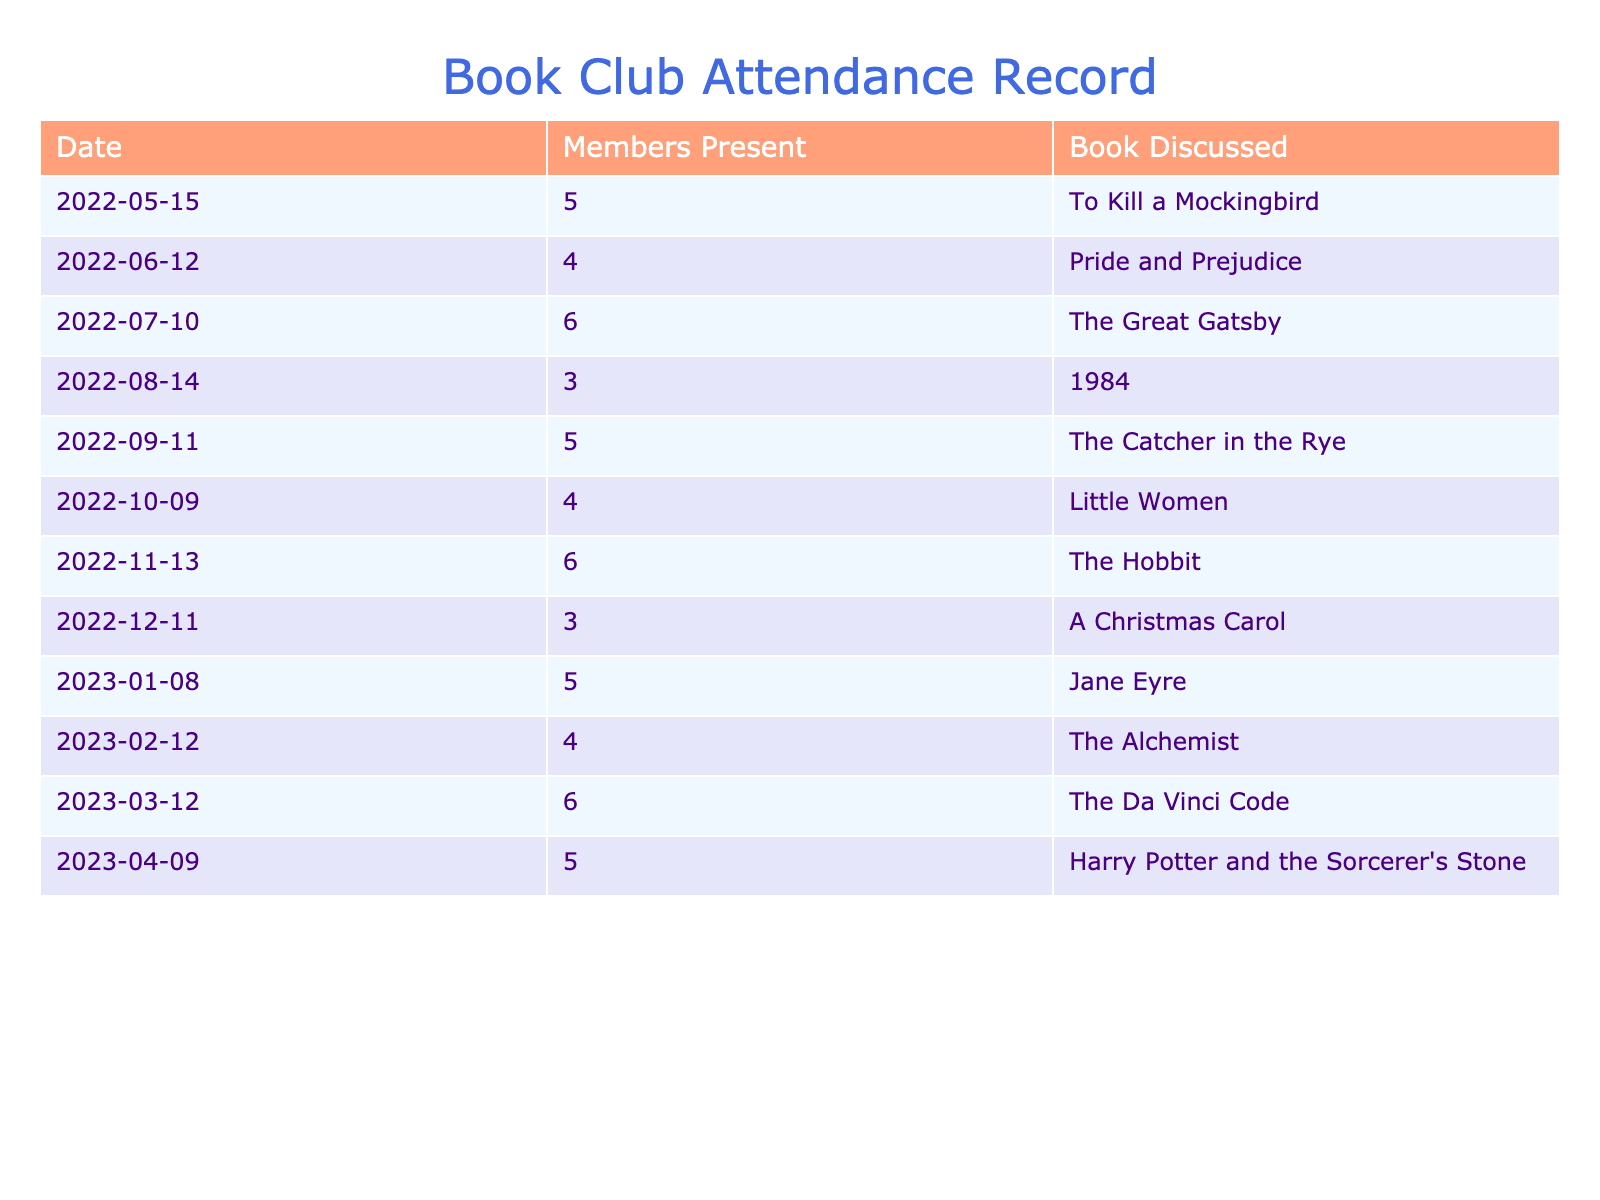What was the highest number of members present at a meeting? Looking through the "Members Present" column, the highest number noted is 6, observed on three occasions: July 10, November 13, and March 12.
Answer: 6 What book was discussed during the meeting with the least members present? The meeting with the least members present had only 3 attendees and occurred on August 14. The book discussed that day was "1984".
Answer: 1984 How many meetings had more than 5 members present? Counting the meetings listed, there are 4 instances where more than 5 members attended: July 10, November 13, and March 12 (each with 6 members), and one with 5 members in May, October, and April (which don't count). Hence, a total of three meetings satisfy this condition.
Answer: 3 What is the average number of members present at the meetings? Adding up the members present from each meeting gives a total of 62 (5 + 4 + 6 + 3 + 5 + 4 + 6 + 3 + 5 + 4 + 6 + 5 = 62). There were 12 meetings, so the average is 62 / 12 = 5.17.
Answer: 5.17 Did more members attend the meetings in the first half of the year compared to the second half? Analyzing the data, the total number of members present in the first half (May - October) is 27 (5 + 4 + 6 + 3 + 5 + 4 = 27) and in the second half (November - April) is 35 (6 + 3 + 5 + 4 + 6 + 5 = 35). Since 27 is less than 35, more members attended in the second half.
Answer: No What was the book discussed when exactly 4 members were present? There were two meetings where exactly 4 members attended: June 12 with "Pride and Prejudice" and February 12 with "The Alchemist".
Answer: Pride and Prejudice; The Alchemist What was the trend in member attendance from May to April? Listing the number of members present in each month's meetings shows a general stability around 5, with fluctuations (5, 4, 6, 3, 5, 4, 6, 3, 5, 4, 6, 5). However, no consistent increase or decrease is evident, leading to a fairly stable trend throughout the year.
Answer: Stable attendance How many different books were discussed throughout the year? Each meeting corresponds to a unique title, and by counting them, there are a total of 12 different books discussed over these meetings (as listed in the "Book Discussed" column).
Answer: 12 What was the attendance during the meeting held in December? In December, there were 3 members present at the meeting.
Answer: 3 Did the book club hold a meeting every month? The data indicates that a meeting was held every month from May 2022 to April 2023, confirming regular monthly meetings.
Answer: Yes 